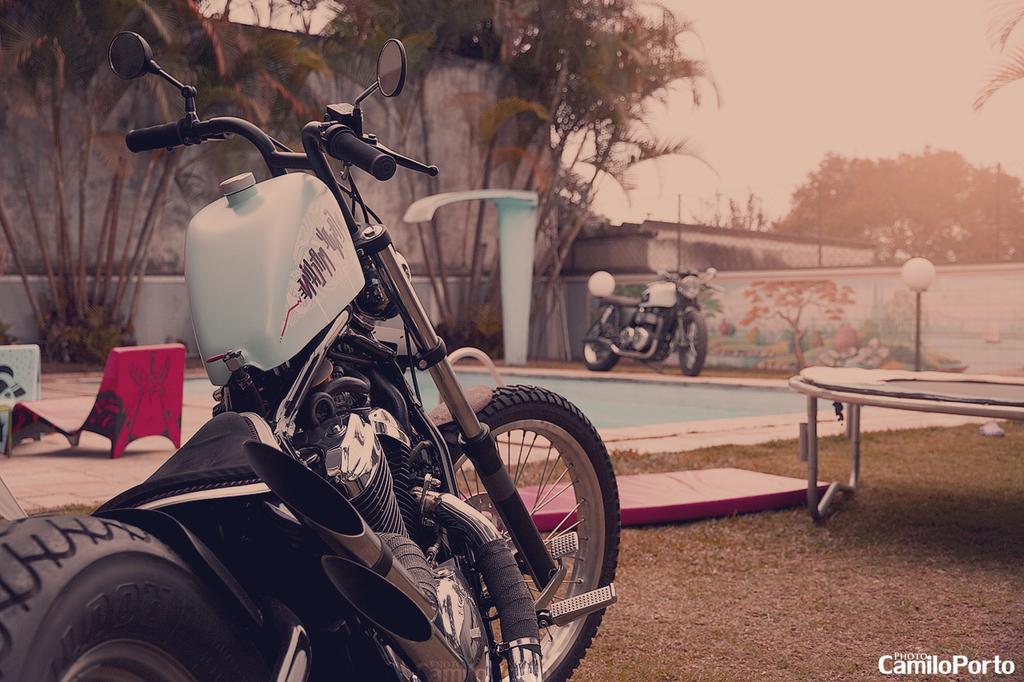How would you summarize this image in a sentence or two? In this image we can see a motorcycle. In the back there is a chair. On the right side there is a trampoline. In the back there is a wall. Also there are trees. And there are light poles. In the background there is sky. 